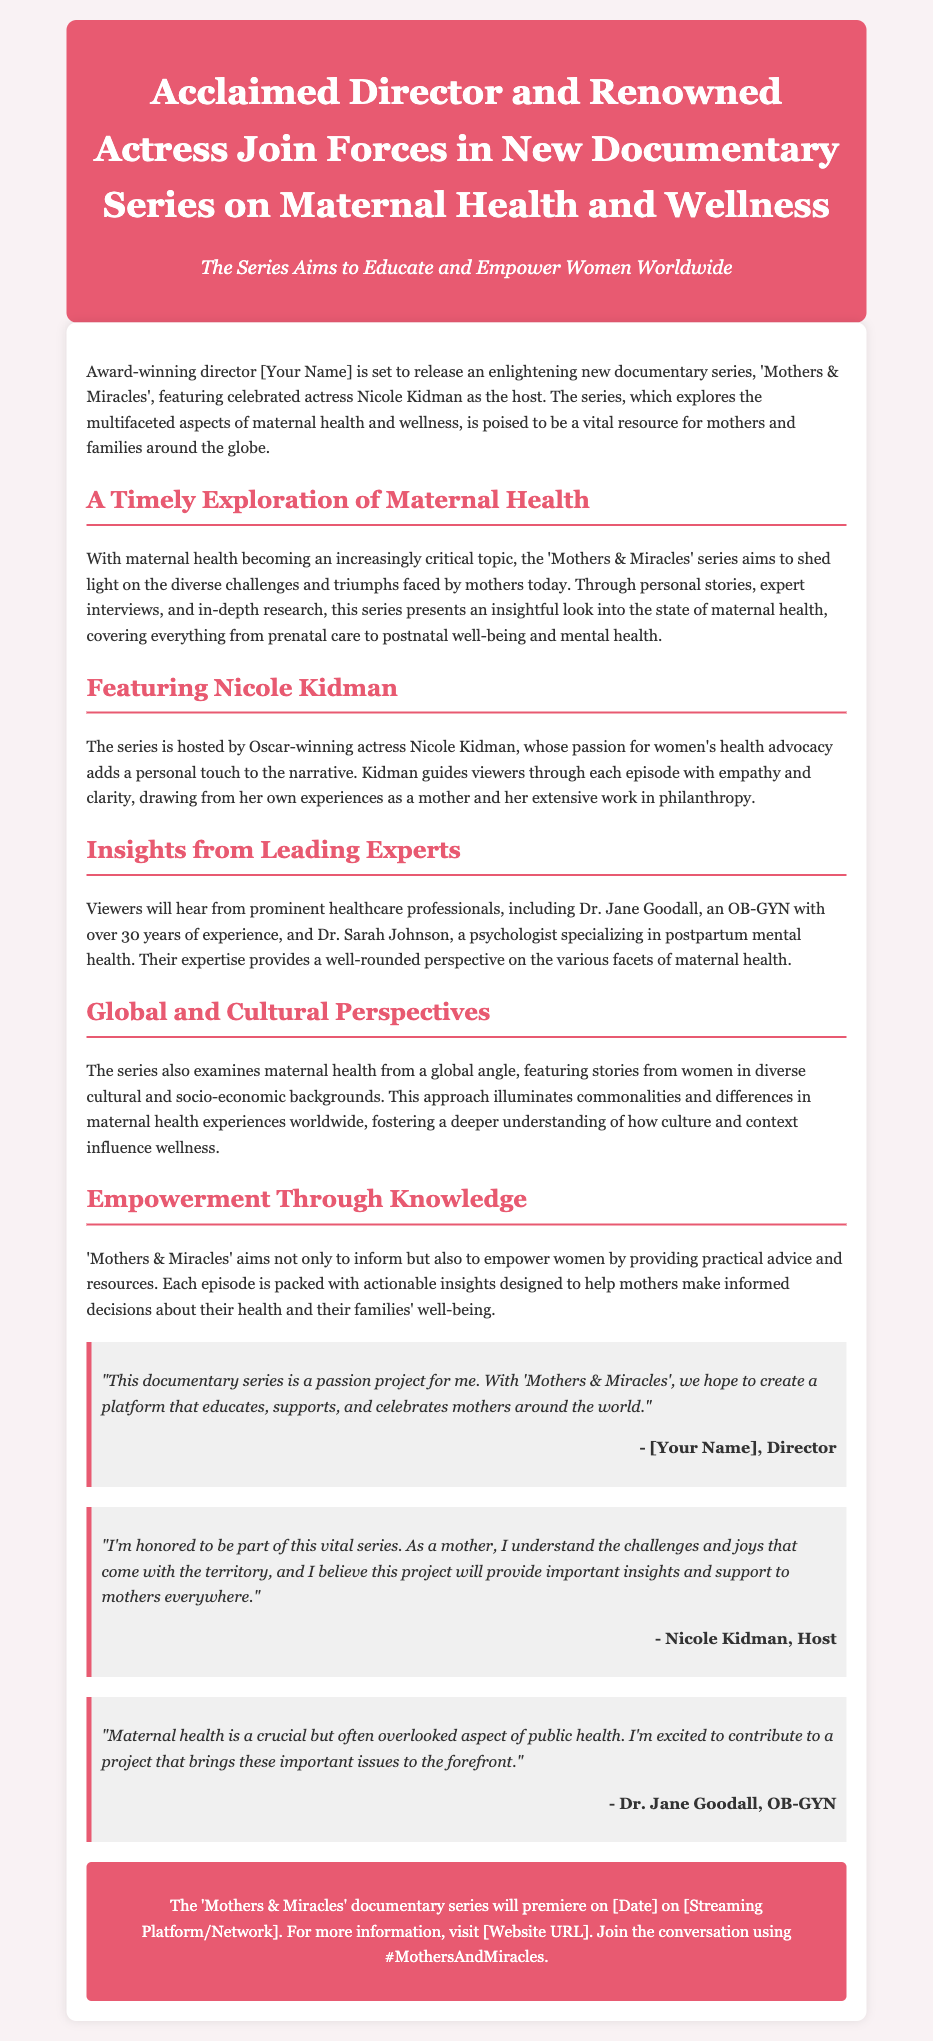What is the title of the documentary series? The title of the documentary series is mentioned in the header of the press release.
Answer: Mothers & Miracles Who is the host of the series? The press release specifies the host of the series in the section about Nicole Kidman.
Answer: Nicole Kidman What is the main focus of the documentary series? The main focus is discussed in the opening paragraph describing the content of the series.
Answer: Maternal health and wellness What type of professionals are featured in the series? The document lists the type of experts contributing to the series in the section about insights from leading experts.
Answer: Healthcare professionals When is the documentary series set to premiere? The premiere date is mentioned in the call-to-action section of the press release.
Answer: [Date] What is a key goal of the 'Mothers & Miracles' series? The goal of the series is outlined in the section titled "Empowerment Through Knowledge."
Answer: To inform and empower women Why does Nicole Kidman feel honored to be part of this series? The reason is provided in her quote, explaining her motivation for participating in the project.
Answer: Understanding the challenges and joys of motherhood Who is Dr. Jane Goodall in relation to the series? Her role is clarified in the section about insights from leading experts.
Answer: An OB-GYN How does the series approach maternal health? The approach is explained in the section discussing global and cultural perspectives.
Answer: Through personal stories and diverse cultural backgrounds What hashtag can be used to join the conversation about the series? The hashtag is included in the call-to-action section.
Answer: #MothersAndMiracles 